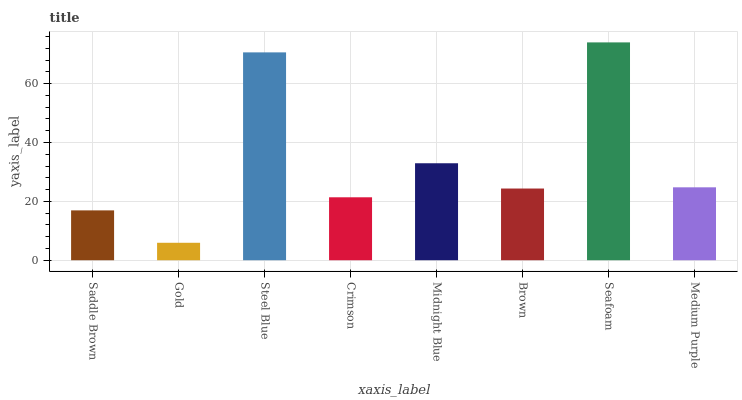Is Steel Blue the minimum?
Answer yes or no. No. Is Steel Blue the maximum?
Answer yes or no. No. Is Steel Blue greater than Gold?
Answer yes or no. Yes. Is Gold less than Steel Blue?
Answer yes or no. Yes. Is Gold greater than Steel Blue?
Answer yes or no. No. Is Steel Blue less than Gold?
Answer yes or no. No. Is Medium Purple the high median?
Answer yes or no. Yes. Is Brown the low median?
Answer yes or no. Yes. Is Gold the high median?
Answer yes or no. No. Is Gold the low median?
Answer yes or no. No. 